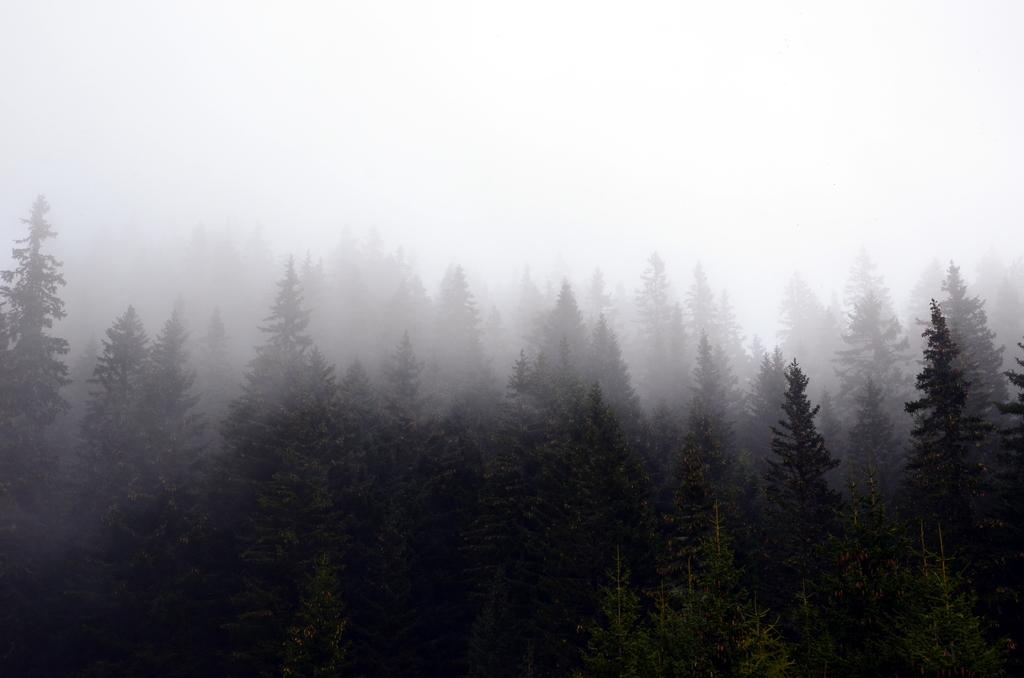What type of vegetation can be seen in the image? There are many trees in the image. What natural phenomenon is present in the center of the image? There is fog in the center of the image. What part of the natural environment is visible in the image? The sky is visible at the top of the image. What scent can be detected from the trees in the image? There is no information about the scent of the trees in the image, so it cannot be determined. 